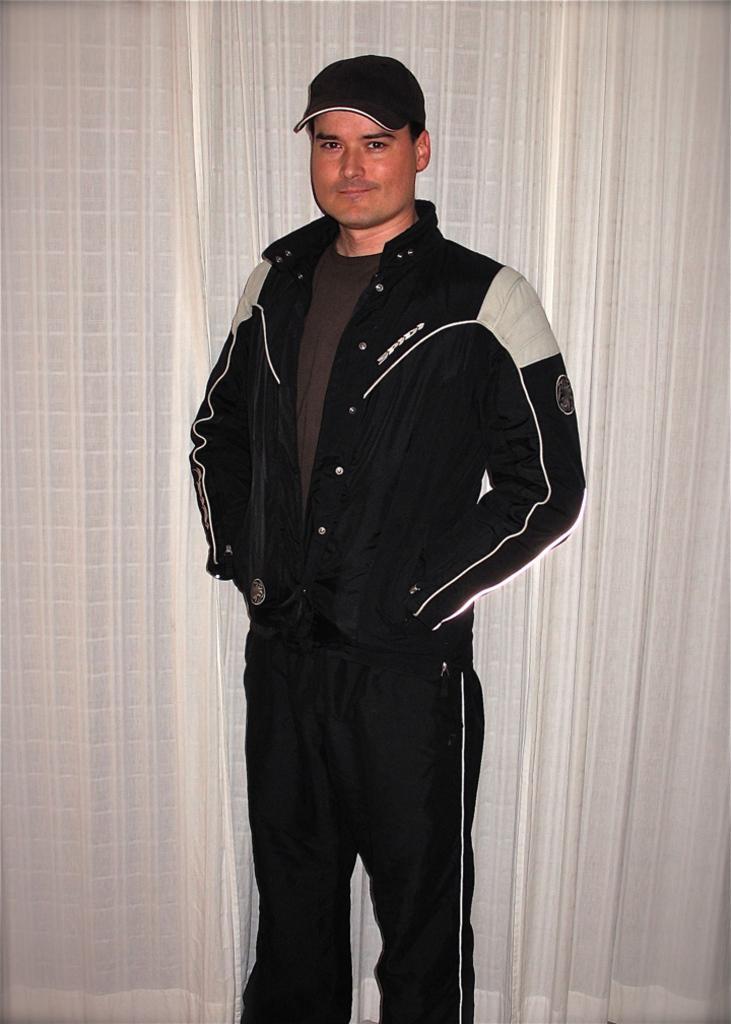Could you give a brief overview of what you see in this image? In this image I can see a person standing and the person is wearing black dress and black color cap. Background the curtains are in white color. 